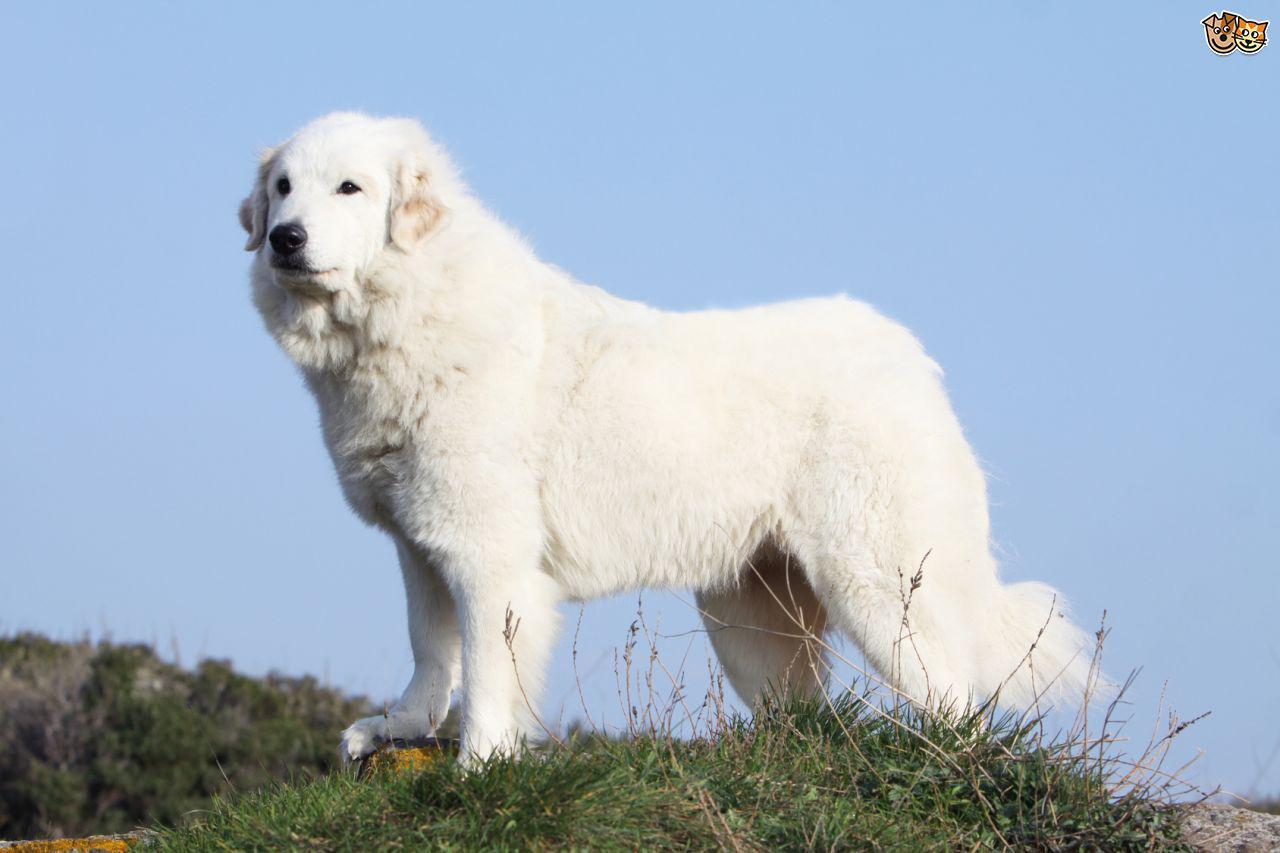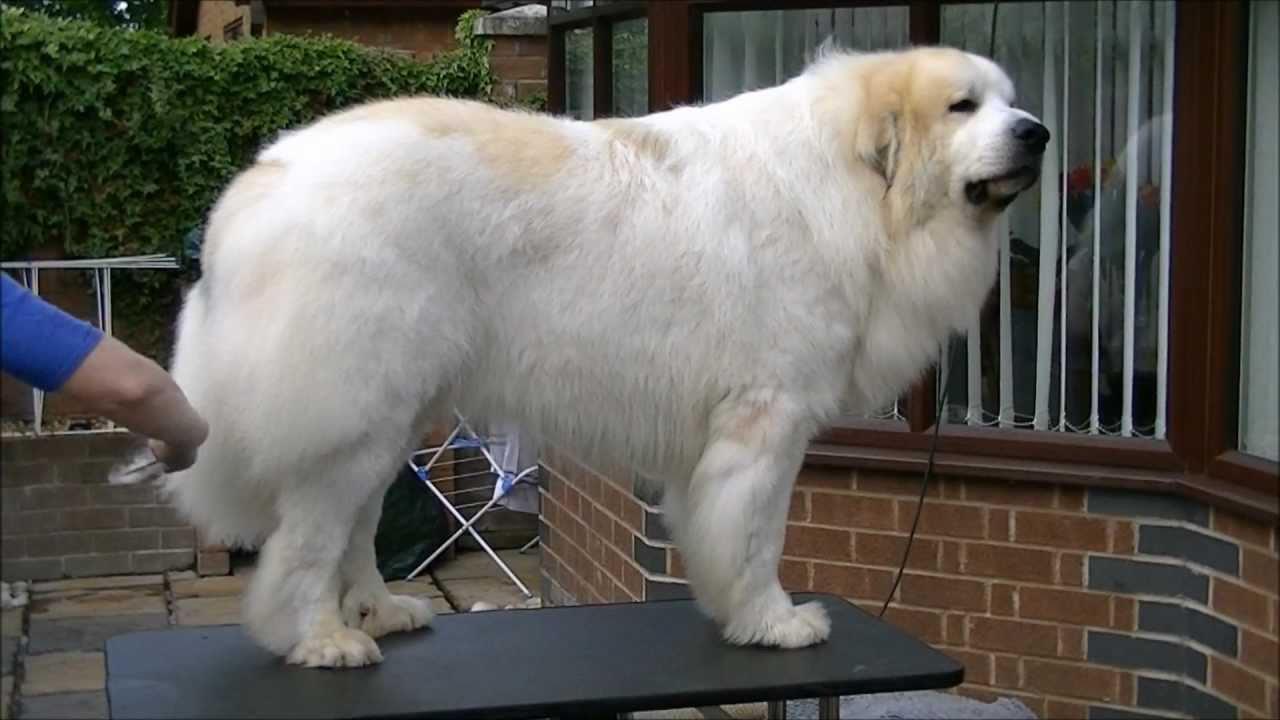The first image is the image on the left, the second image is the image on the right. Evaluate the accuracy of this statement regarding the images: "There are two dogs". Is it true? Answer yes or no. Yes. 